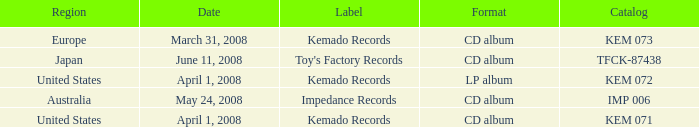Which Format has a Region of united states, and a Catalog of kem 072? LP album. 